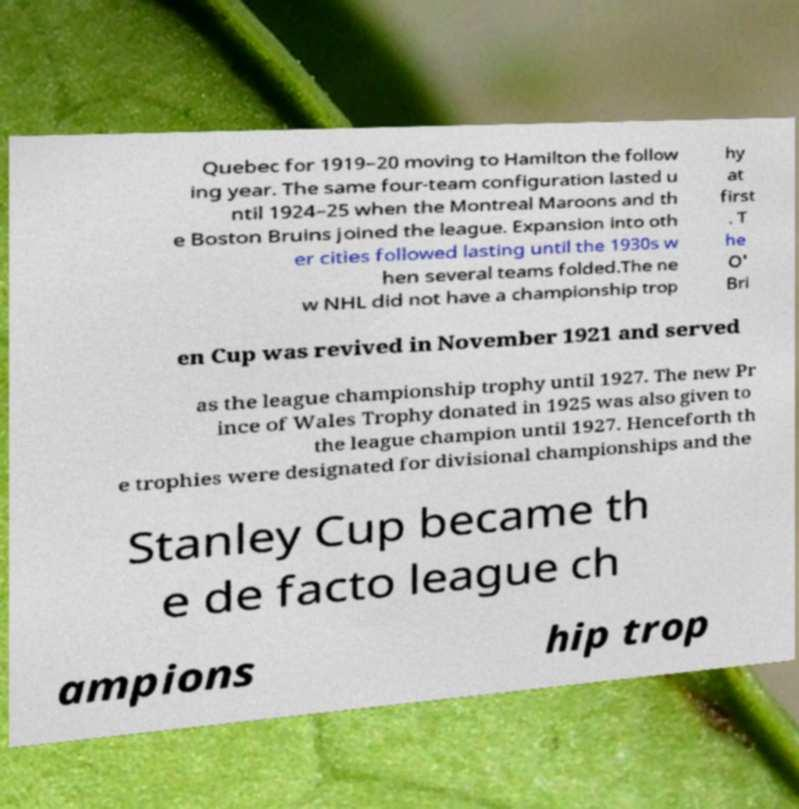Can you accurately transcribe the text from the provided image for me? Quebec for 1919–20 moving to Hamilton the follow ing year. The same four-team configuration lasted u ntil 1924–25 when the Montreal Maroons and th e Boston Bruins joined the league. Expansion into oth er cities followed lasting until the 1930s w hen several teams folded.The ne w NHL did not have a championship trop hy at first . T he O' Bri en Cup was revived in November 1921 and served as the league championship trophy until 1927. The new Pr ince of Wales Trophy donated in 1925 was also given to the league champion until 1927. Henceforth th e trophies were designated for divisional championships and the Stanley Cup became th e de facto league ch ampions hip trop 